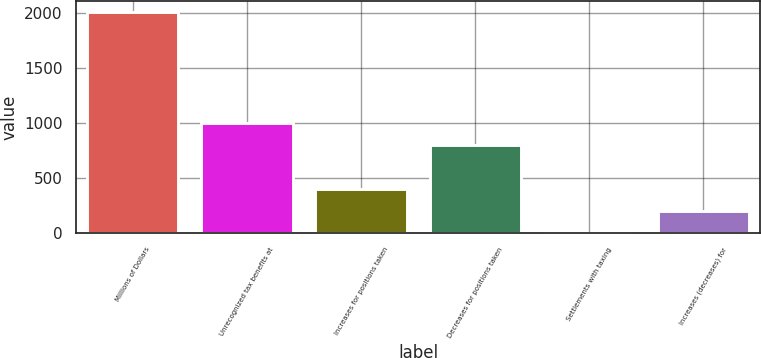<chart> <loc_0><loc_0><loc_500><loc_500><bar_chart><fcel>Millions of Dollars<fcel>Unrecognized tax benefits at<fcel>Increases for positions taken<fcel>Decreases for positions taken<fcel>Settlements with taxing<fcel>Increases (decreases) for<nl><fcel>2007<fcel>1004<fcel>402.2<fcel>803.4<fcel>1<fcel>201.6<nl></chart> 